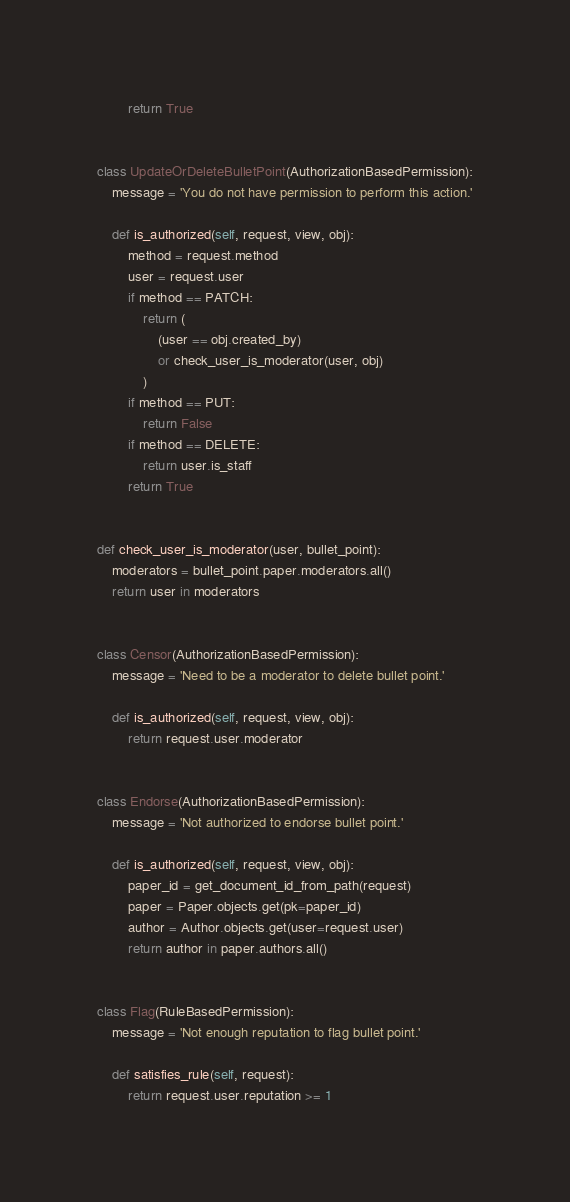Convert code to text. <code><loc_0><loc_0><loc_500><loc_500><_Python_>        return True


class UpdateOrDeleteBulletPoint(AuthorizationBasedPermission):
    message = 'You do not have permission to perform this action.'

    def is_authorized(self, request, view, obj):
        method = request.method
        user = request.user
        if method == PATCH:
            return (
                (user == obj.created_by)
                or check_user_is_moderator(user, obj)
            )
        if method == PUT:
            return False
        if method == DELETE:
            return user.is_staff
        return True


def check_user_is_moderator(user, bullet_point):
    moderators = bullet_point.paper.moderators.all()
    return user in moderators


class Censor(AuthorizationBasedPermission):
    message = 'Need to be a moderator to delete bullet point.'

    def is_authorized(self, request, view, obj):
        return request.user.moderator


class Endorse(AuthorizationBasedPermission):
    message = 'Not authorized to endorse bullet point.'

    def is_authorized(self, request, view, obj):
        paper_id = get_document_id_from_path(request)
        paper = Paper.objects.get(pk=paper_id)
        author = Author.objects.get(user=request.user)
        return author in paper.authors.all()


class Flag(RuleBasedPermission):
    message = 'Not enough reputation to flag bullet point.'

    def satisfies_rule(self, request):
        return request.user.reputation >= 1
</code> 